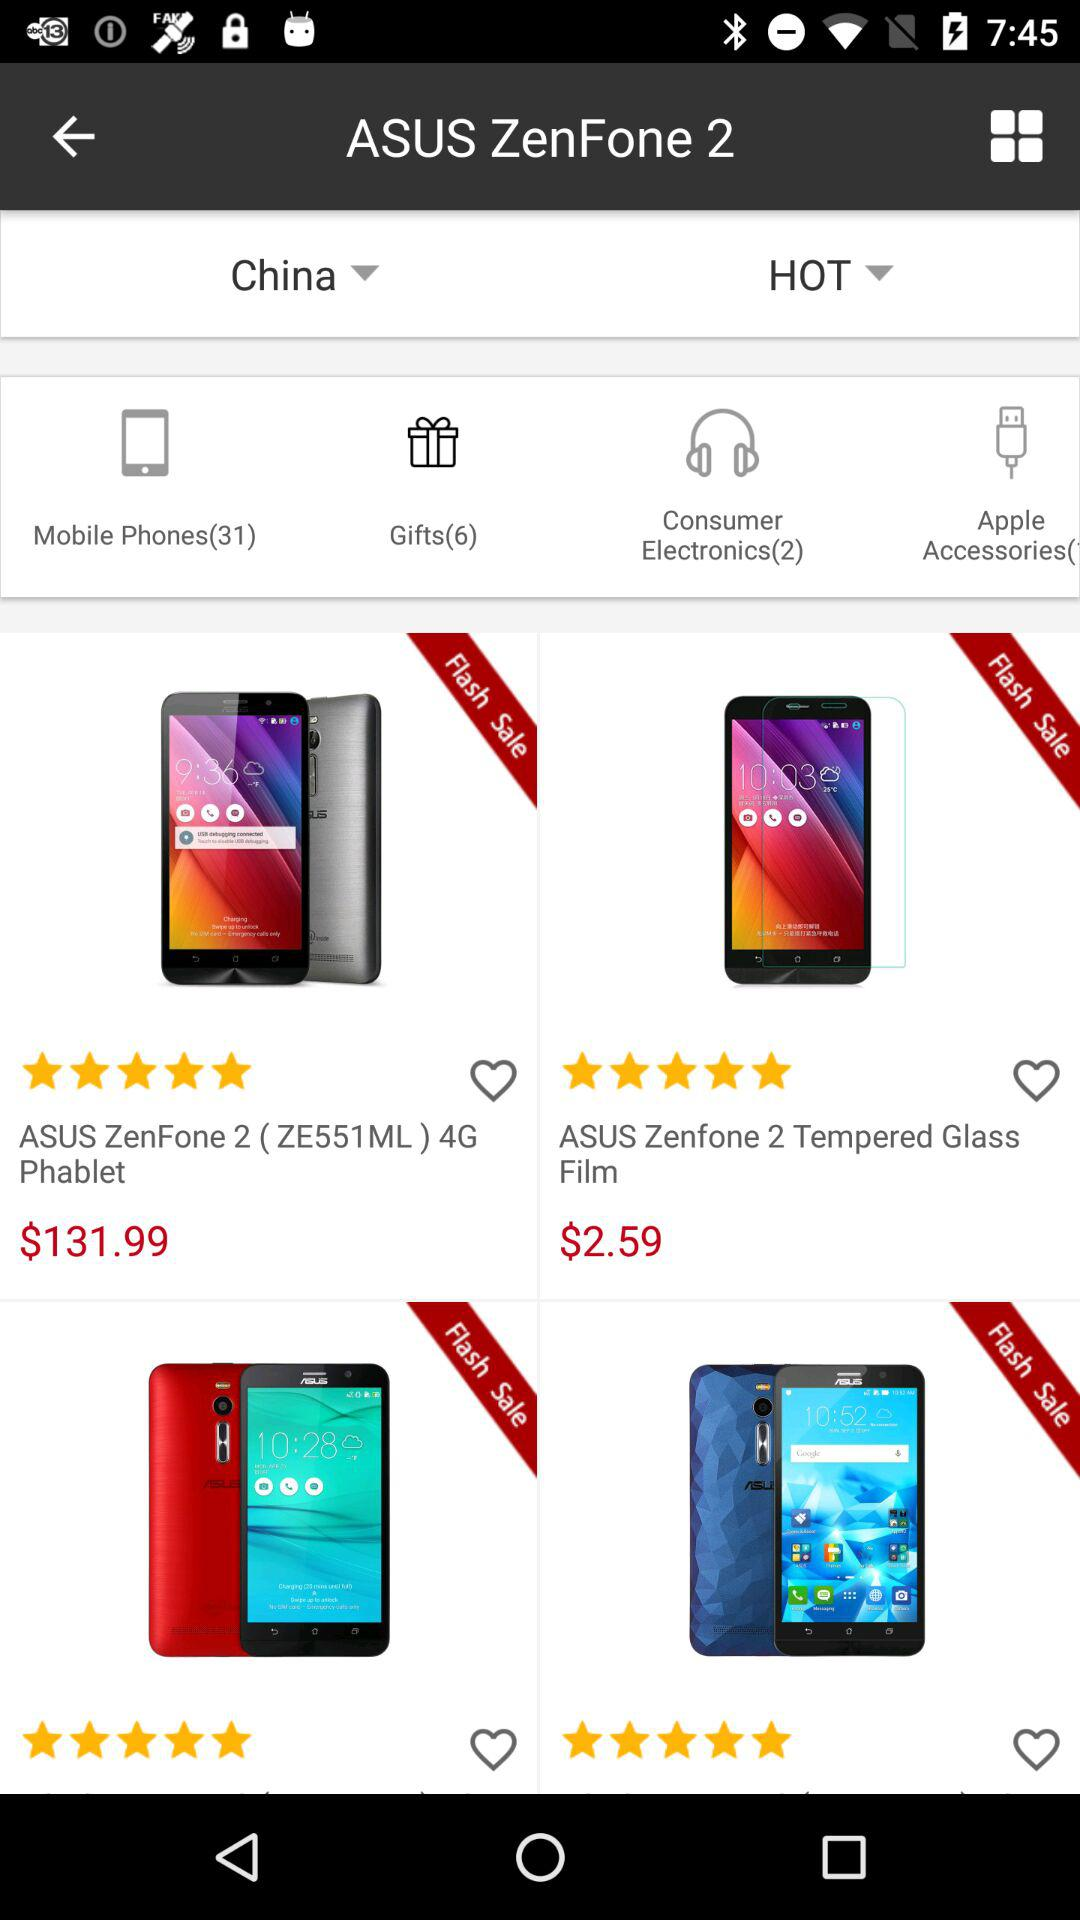Which countries are available to select?
When the provided information is insufficient, respond with <no answer>. <no answer> 